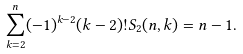Convert formula to latex. <formula><loc_0><loc_0><loc_500><loc_500>\sum _ { k = 2 } ^ { n } ( - 1 ) ^ { k - 2 } ( k - 2 ) ! S _ { 2 } ( n , k ) = n - 1 .</formula> 